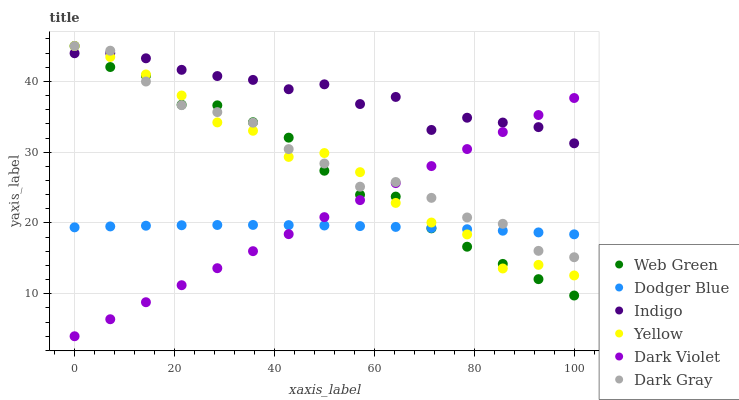Does Dodger Blue have the minimum area under the curve?
Answer yes or no. Yes. Does Indigo have the maximum area under the curve?
Answer yes or no. Yes. Does Dark Violet have the minimum area under the curve?
Answer yes or no. No. Does Dark Violet have the maximum area under the curve?
Answer yes or no. No. Is Dark Violet the smoothest?
Answer yes or no. Yes. Is Yellow the roughest?
Answer yes or no. Yes. Is Indigo the smoothest?
Answer yes or no. No. Is Indigo the roughest?
Answer yes or no. No. Does Dark Violet have the lowest value?
Answer yes or no. Yes. Does Indigo have the lowest value?
Answer yes or no. No. Does Yellow have the highest value?
Answer yes or no. Yes. Does Indigo have the highest value?
Answer yes or no. No. Is Dodger Blue less than Indigo?
Answer yes or no. Yes. Is Indigo greater than Dodger Blue?
Answer yes or no. Yes. Does Dark Gray intersect Web Green?
Answer yes or no. Yes. Is Dark Gray less than Web Green?
Answer yes or no. No. Is Dark Gray greater than Web Green?
Answer yes or no. No. Does Dodger Blue intersect Indigo?
Answer yes or no. No. 